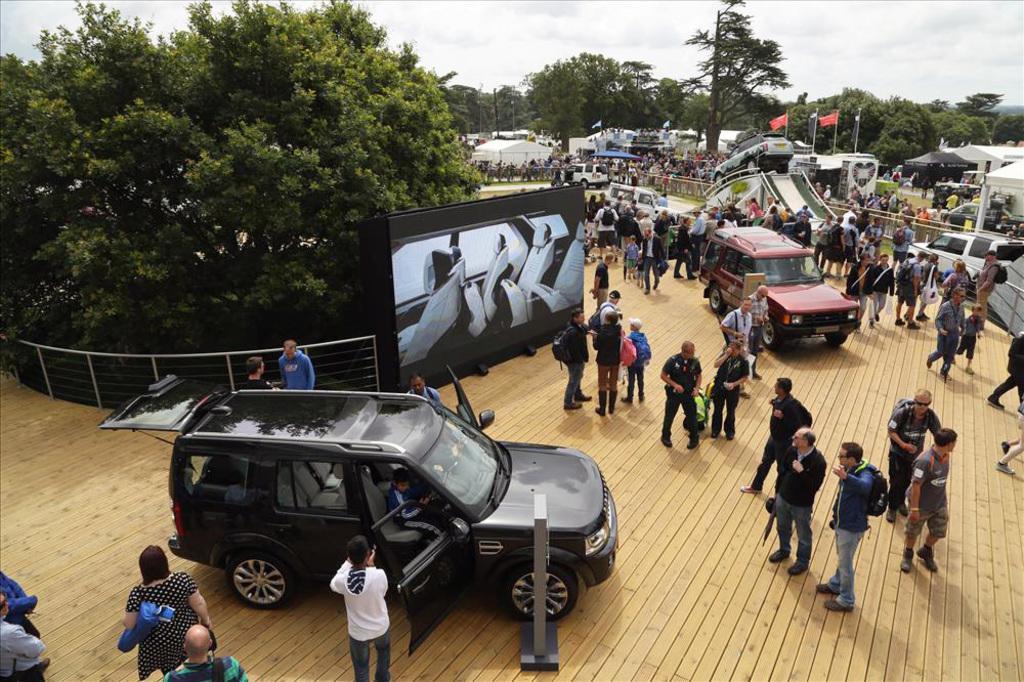In one or two sentences, can you explain what this image depicts? In this image we can see a group of people and some vehicles on the ground. We can also see a fence, a board with some pictures on it, a car on a ramp, a group of trees, some houses with roof, tents, and outdoor umbrella, some poles, the flags and the sky which looks cloudy. 